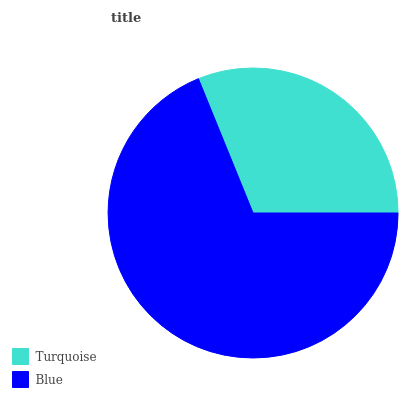Is Turquoise the minimum?
Answer yes or no. Yes. Is Blue the maximum?
Answer yes or no. Yes. Is Blue the minimum?
Answer yes or no. No. Is Blue greater than Turquoise?
Answer yes or no. Yes. Is Turquoise less than Blue?
Answer yes or no. Yes. Is Turquoise greater than Blue?
Answer yes or no. No. Is Blue less than Turquoise?
Answer yes or no. No. Is Blue the high median?
Answer yes or no. Yes. Is Turquoise the low median?
Answer yes or no. Yes. Is Turquoise the high median?
Answer yes or no. No. Is Blue the low median?
Answer yes or no. No. 